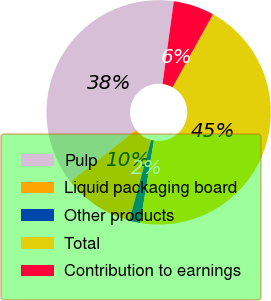Convert chart to OTSL. <chart><loc_0><loc_0><loc_500><loc_500><pie_chart><fcel>Pulp<fcel>Liquid packaging board<fcel>Other products<fcel>Total<fcel>Contribution to earnings<nl><fcel>37.76%<fcel>10.19%<fcel>1.59%<fcel>44.57%<fcel>5.89%<nl></chart> 